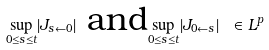<formula> <loc_0><loc_0><loc_500><loc_500>\underset { 0 \leq s \leq t } { \sup } | J _ { s \leftarrow 0 } | \text { and} \underset { 0 \leq s \leq t } { \sup } | J _ { 0 \leftarrow s } | \text { } \in L ^ { p }</formula> 